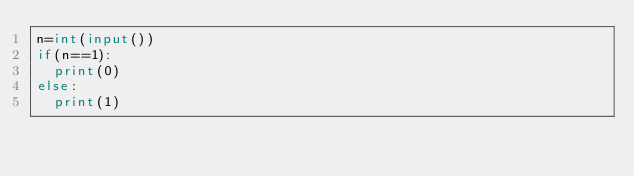Convert code to text. <code><loc_0><loc_0><loc_500><loc_500><_Python_>n=int(input())
if(n==1):
  print(0)
else:
  print(1)</code> 